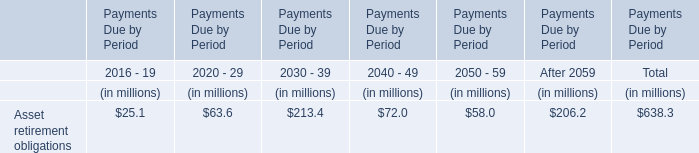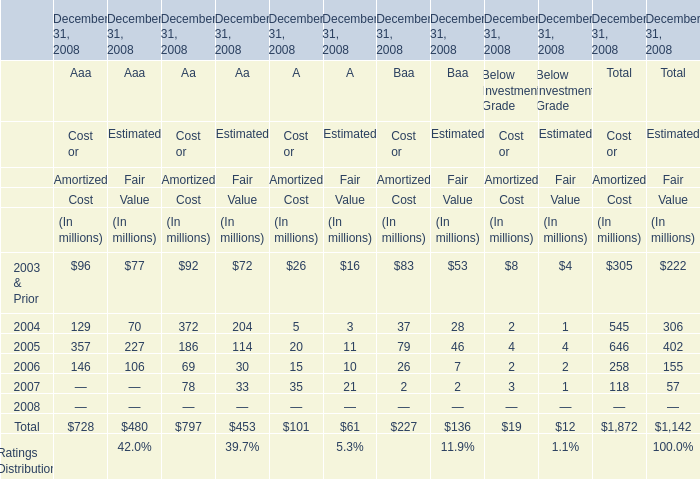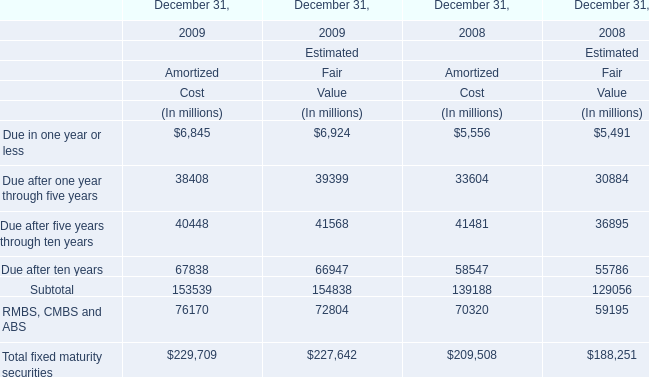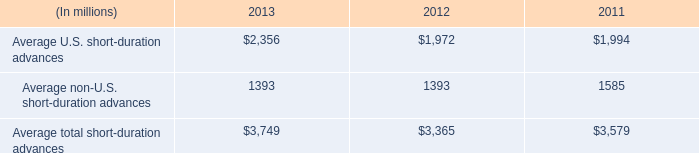How many elements for Amortized Cost show value that is less than 10000 million in 2009? 
Answer: 1. 